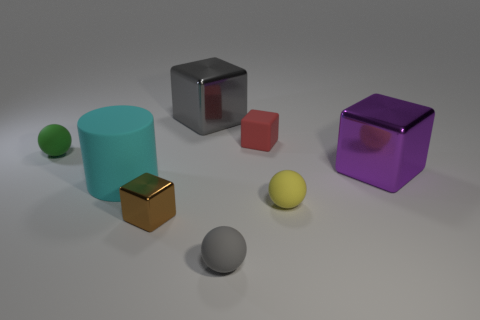Is the number of cubes in front of the large purple shiny block greater than the number of gray metal cylinders?
Provide a succinct answer. Yes. Is the shape of the tiny green rubber thing the same as the yellow rubber object?
Provide a succinct answer. Yes. How many large purple spheres are the same material as the large cylinder?
Your answer should be very brief. 0. What is the size of the gray thing that is the same shape as the purple metal object?
Keep it short and to the point. Large. Do the gray metallic block and the gray ball have the same size?
Give a very brief answer. No. What shape is the gray thing that is in front of the big cube behind the ball that is behind the cyan cylinder?
Offer a terse response. Sphere. There is another small object that is the same shape as the tiny red rubber object; what color is it?
Keep it short and to the point. Brown. There is a shiny thing that is behind the large cyan rubber cylinder and left of the yellow object; what size is it?
Offer a very short reply. Large. There is a large metallic cube behind the large metal block that is right of the small gray matte sphere; what number of shiny cubes are to the right of it?
Offer a terse response. 1. How many small objects are either gray blocks or brown cubes?
Offer a very short reply. 1. 